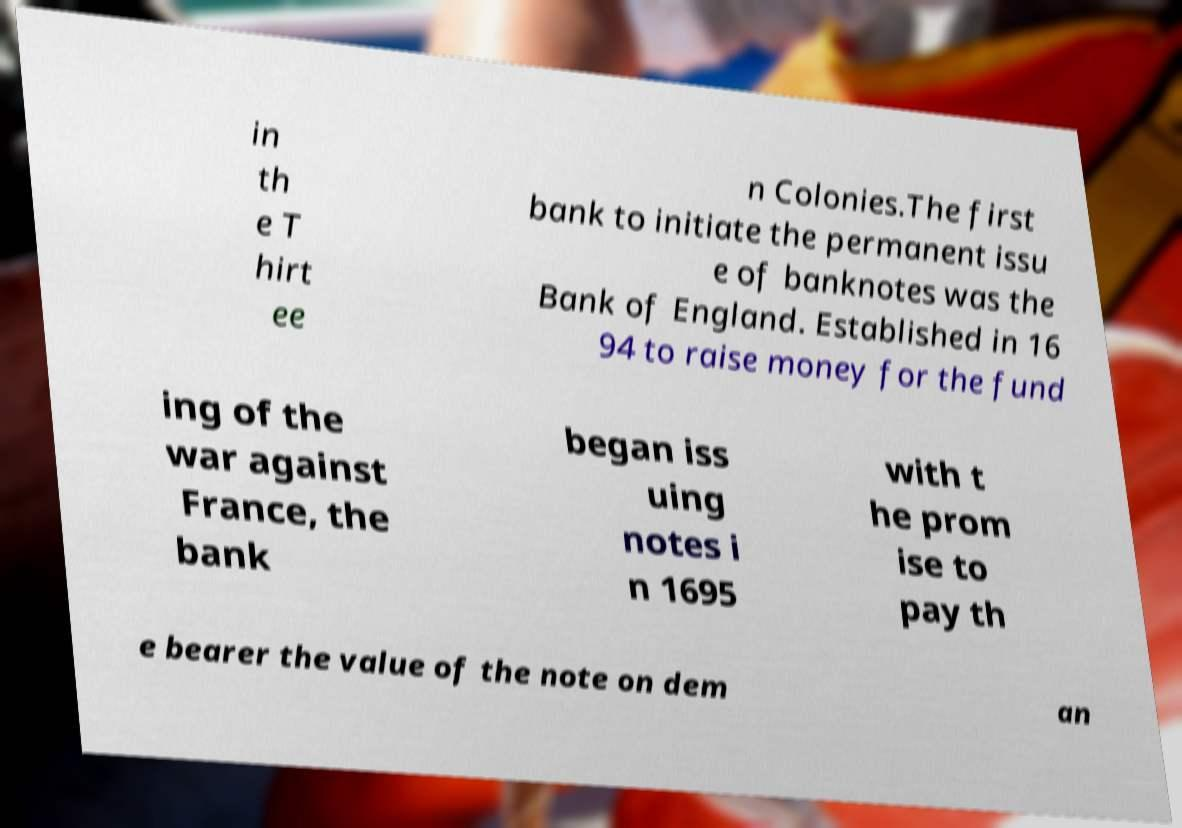Could you assist in decoding the text presented in this image and type it out clearly? in th e T hirt ee n Colonies.The first bank to initiate the permanent issu e of banknotes was the Bank of England. Established in 16 94 to raise money for the fund ing of the war against France, the bank began iss uing notes i n 1695 with t he prom ise to pay th e bearer the value of the note on dem an 